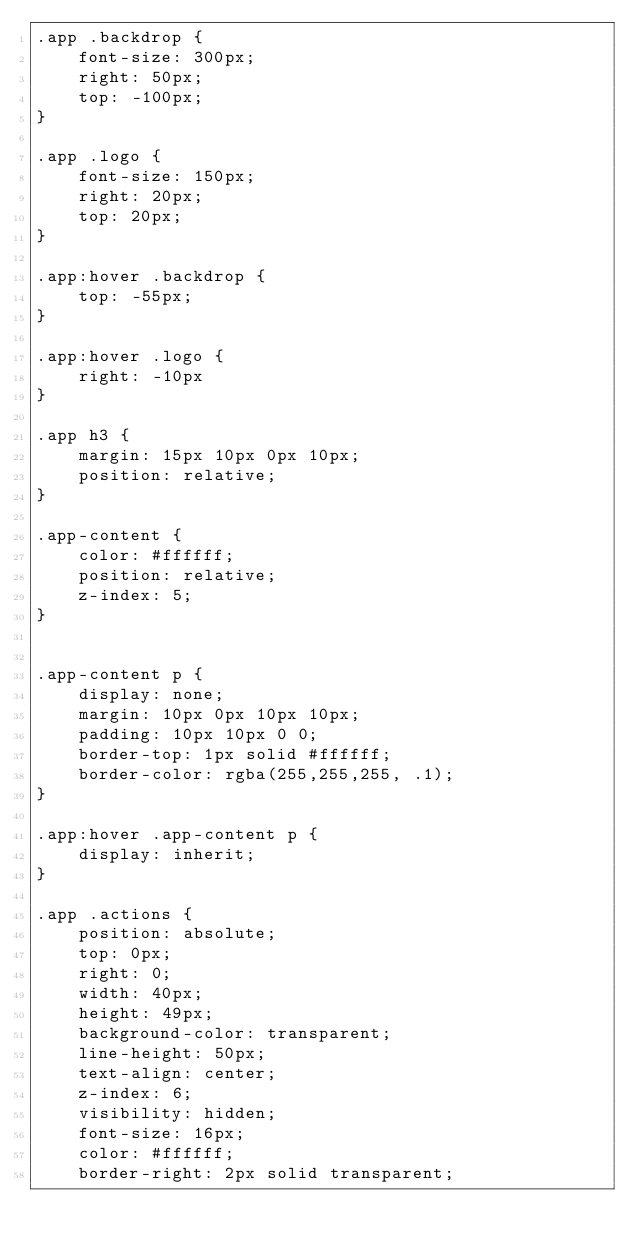Convert code to text. <code><loc_0><loc_0><loc_500><loc_500><_CSS_>.app .backdrop {
    font-size: 300px;
    right: 50px;
    top: -100px;
}

.app .logo {
    font-size: 150px;
    right: 20px;
    top: 20px;
}

.app:hover .backdrop {
    top: -55px;
}

.app:hover .logo {
    right: -10px
}

.app h3 {
    margin: 15px 10px 0px 10px;
    position: relative;
}

.app-content {
    color: #ffffff;
    position: relative;
    z-index: 5;
}


.app-content p {
    display: none;
    margin: 10px 0px 10px 10px;
    padding: 10px 10px 0 0;
    border-top: 1px solid #ffffff;
    border-color: rgba(255,255,255, .1);
}

.app:hover .app-content p {
    display: inherit;
}

.app .actions {
    position: absolute;
    top: 0px;
    right: 0;
    width: 40px;
    height: 49px;
    background-color: transparent;
    line-height: 50px;
    text-align: center;
    z-index: 6;
    visibility: hidden;
    font-size: 16px;
    color: #ffffff;
    border-right: 2px solid transparent;</code> 